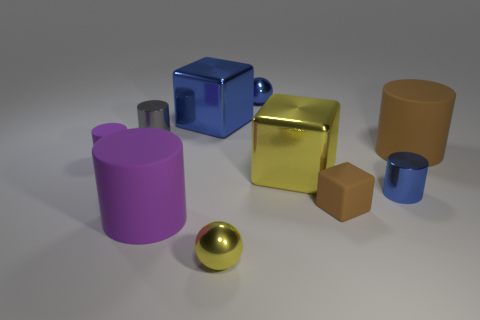There is a big yellow metallic object; does it have the same shape as the large metallic object that is to the left of the tiny yellow shiny ball?
Keep it short and to the point. Yes. How many small cylinders are on the right side of the tiny gray cylinder and to the left of the brown rubber cube?
Your response must be concise. 0. Is the material of the big yellow cube the same as the tiny blue thing behind the big brown rubber cylinder?
Your response must be concise. Yes. Is the number of tiny yellow balls that are behind the large yellow metal thing the same as the number of big metal cubes?
Keep it short and to the point. No. There is a big metallic object that is to the right of the yellow metal ball; what color is it?
Make the answer very short. Yellow. How many other things are the same color as the small cube?
Make the answer very short. 1. Is there anything else that is the same size as the brown matte cube?
Make the answer very short. Yes. There is a metal ball that is in front of the gray thing; is it the same size as the small gray shiny cylinder?
Ensure brevity in your answer.  Yes. What is the material of the big cylinder that is behind the large purple cylinder?
Offer a very short reply. Rubber. Is there anything else that has the same shape as the large yellow object?
Provide a short and direct response. Yes. 